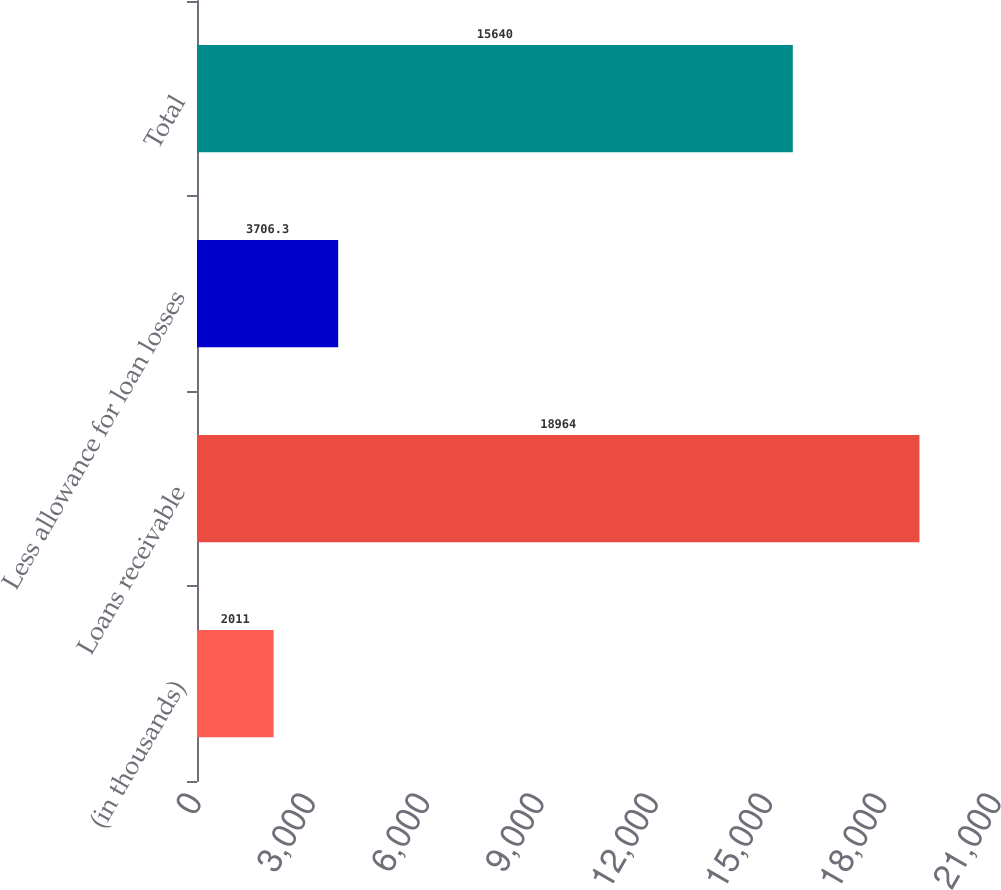Convert chart to OTSL. <chart><loc_0><loc_0><loc_500><loc_500><bar_chart><fcel>(in thousands)<fcel>Loans receivable<fcel>Less allowance for loan losses<fcel>Total<nl><fcel>2011<fcel>18964<fcel>3706.3<fcel>15640<nl></chart> 